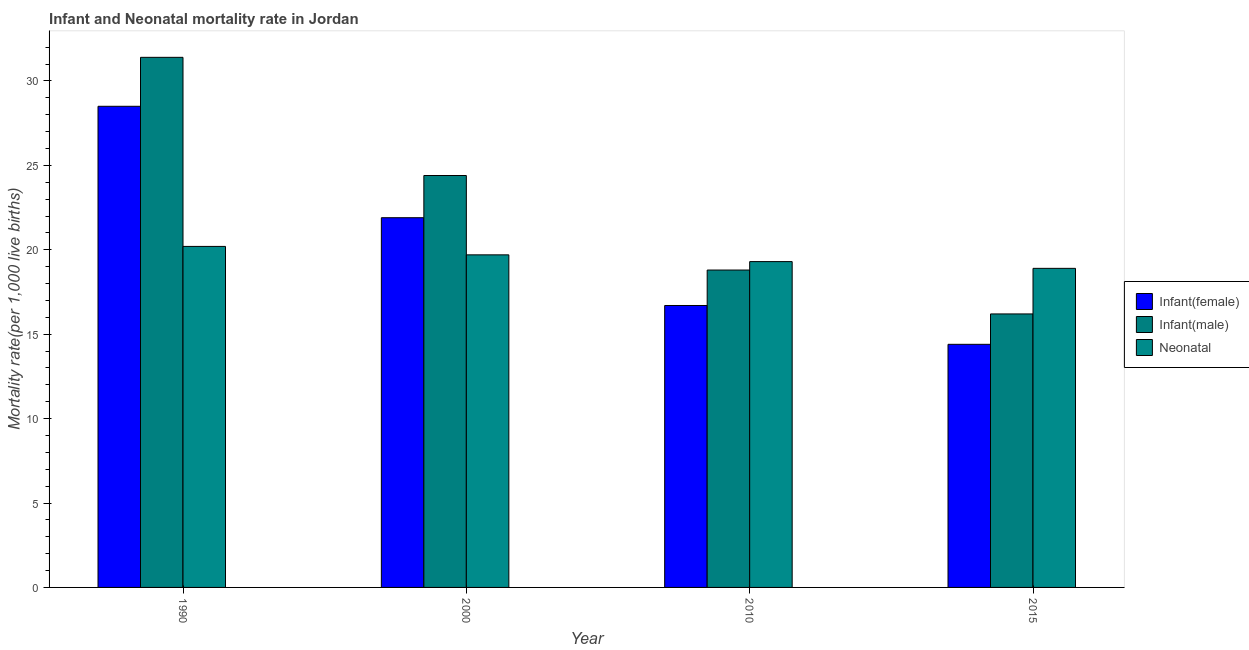How many different coloured bars are there?
Give a very brief answer. 3. Are the number of bars per tick equal to the number of legend labels?
Make the answer very short. Yes. Across all years, what is the maximum neonatal mortality rate?
Provide a succinct answer. 20.2. Across all years, what is the minimum infant mortality rate(female)?
Ensure brevity in your answer.  14.4. In which year was the infant mortality rate(male) minimum?
Keep it short and to the point. 2015. What is the total infant mortality rate(male) in the graph?
Keep it short and to the point. 90.8. What is the difference between the neonatal mortality rate in 2010 and the infant mortality rate(female) in 2015?
Provide a short and direct response. 0.4. What is the average infant mortality rate(female) per year?
Give a very brief answer. 20.38. In the year 1990, what is the difference between the neonatal mortality rate and infant mortality rate(female)?
Your answer should be very brief. 0. In how many years, is the neonatal mortality rate greater than 21?
Offer a terse response. 0. What is the ratio of the neonatal mortality rate in 1990 to that in 2015?
Provide a short and direct response. 1.07. Is the infant mortality rate(male) in 2000 less than that in 2010?
Your answer should be very brief. No. Is the difference between the infant mortality rate(male) in 2000 and 2015 greater than the difference between the neonatal mortality rate in 2000 and 2015?
Make the answer very short. No. What is the difference between the highest and the second highest infant mortality rate(female)?
Offer a terse response. 6.6. What is the difference between the highest and the lowest neonatal mortality rate?
Your answer should be compact. 1.3. What does the 2nd bar from the left in 2015 represents?
Give a very brief answer. Infant(male). What does the 2nd bar from the right in 2000 represents?
Provide a short and direct response. Infant(male). Is it the case that in every year, the sum of the infant mortality rate(female) and infant mortality rate(male) is greater than the neonatal mortality rate?
Your answer should be very brief. Yes. How many years are there in the graph?
Make the answer very short. 4. Does the graph contain any zero values?
Keep it short and to the point. No. How many legend labels are there?
Give a very brief answer. 3. How are the legend labels stacked?
Provide a short and direct response. Vertical. What is the title of the graph?
Offer a terse response. Infant and Neonatal mortality rate in Jordan. What is the label or title of the Y-axis?
Your response must be concise. Mortality rate(per 1,0 live births). What is the Mortality rate(per 1,000 live births) of Infant(female) in 1990?
Keep it short and to the point. 28.5. What is the Mortality rate(per 1,000 live births) of Infant(male) in 1990?
Offer a very short reply. 31.4. What is the Mortality rate(per 1,000 live births) of Neonatal  in 1990?
Give a very brief answer. 20.2. What is the Mortality rate(per 1,000 live births) of Infant(female) in 2000?
Offer a terse response. 21.9. What is the Mortality rate(per 1,000 live births) in Infant(male) in 2000?
Your answer should be compact. 24.4. What is the Mortality rate(per 1,000 live births) of Infant(female) in 2010?
Your answer should be very brief. 16.7. What is the Mortality rate(per 1,000 live births) of Infant(male) in 2010?
Your response must be concise. 18.8. What is the Mortality rate(per 1,000 live births) in Neonatal  in 2010?
Give a very brief answer. 19.3. What is the Mortality rate(per 1,000 live births) in Infant(female) in 2015?
Offer a very short reply. 14.4. What is the Mortality rate(per 1,000 live births) in Infant(male) in 2015?
Offer a very short reply. 16.2. Across all years, what is the maximum Mortality rate(per 1,000 live births) in Infant(male)?
Ensure brevity in your answer.  31.4. Across all years, what is the maximum Mortality rate(per 1,000 live births) of Neonatal ?
Provide a short and direct response. 20.2. Across all years, what is the minimum Mortality rate(per 1,000 live births) in Neonatal ?
Your answer should be very brief. 18.9. What is the total Mortality rate(per 1,000 live births) of Infant(female) in the graph?
Give a very brief answer. 81.5. What is the total Mortality rate(per 1,000 live births) in Infant(male) in the graph?
Offer a terse response. 90.8. What is the total Mortality rate(per 1,000 live births) in Neonatal  in the graph?
Ensure brevity in your answer.  78.1. What is the difference between the Mortality rate(per 1,000 live births) of Infant(female) in 1990 and that in 2010?
Your response must be concise. 11.8. What is the difference between the Mortality rate(per 1,000 live births) in Neonatal  in 1990 and that in 2010?
Keep it short and to the point. 0.9. What is the difference between the Mortality rate(per 1,000 live births) in Infant(male) in 1990 and that in 2015?
Give a very brief answer. 15.2. What is the difference between the Mortality rate(per 1,000 live births) of Infant(female) in 2000 and that in 2010?
Keep it short and to the point. 5.2. What is the difference between the Mortality rate(per 1,000 live births) of Infant(male) in 2000 and that in 2010?
Ensure brevity in your answer.  5.6. What is the difference between the Mortality rate(per 1,000 live births) in Neonatal  in 2000 and that in 2010?
Offer a terse response. 0.4. What is the difference between the Mortality rate(per 1,000 live births) of Infant(female) in 2010 and that in 2015?
Your response must be concise. 2.3. What is the difference between the Mortality rate(per 1,000 live births) of Neonatal  in 2010 and that in 2015?
Your response must be concise. 0.4. What is the difference between the Mortality rate(per 1,000 live births) in Infant(female) in 1990 and the Mortality rate(per 1,000 live births) in Neonatal  in 2000?
Provide a succinct answer. 8.8. What is the difference between the Mortality rate(per 1,000 live births) of Infant(male) in 1990 and the Mortality rate(per 1,000 live births) of Neonatal  in 2000?
Offer a very short reply. 11.7. What is the difference between the Mortality rate(per 1,000 live births) of Infant(female) in 1990 and the Mortality rate(per 1,000 live births) of Infant(male) in 2010?
Ensure brevity in your answer.  9.7. What is the difference between the Mortality rate(per 1,000 live births) of Infant(male) in 1990 and the Mortality rate(per 1,000 live births) of Neonatal  in 2010?
Offer a very short reply. 12.1. What is the difference between the Mortality rate(per 1,000 live births) of Infant(male) in 1990 and the Mortality rate(per 1,000 live births) of Neonatal  in 2015?
Your answer should be very brief. 12.5. What is the difference between the Mortality rate(per 1,000 live births) of Infant(female) in 2000 and the Mortality rate(per 1,000 live births) of Infant(male) in 2010?
Ensure brevity in your answer.  3.1. What is the difference between the Mortality rate(per 1,000 live births) in Infant(female) in 2000 and the Mortality rate(per 1,000 live births) in Neonatal  in 2015?
Ensure brevity in your answer.  3. What is the difference between the Mortality rate(per 1,000 live births) in Infant(male) in 2000 and the Mortality rate(per 1,000 live births) in Neonatal  in 2015?
Keep it short and to the point. 5.5. What is the difference between the Mortality rate(per 1,000 live births) of Infant(female) in 2010 and the Mortality rate(per 1,000 live births) of Neonatal  in 2015?
Your answer should be compact. -2.2. What is the difference between the Mortality rate(per 1,000 live births) in Infant(male) in 2010 and the Mortality rate(per 1,000 live births) in Neonatal  in 2015?
Provide a short and direct response. -0.1. What is the average Mortality rate(per 1,000 live births) in Infant(female) per year?
Your answer should be compact. 20.38. What is the average Mortality rate(per 1,000 live births) in Infant(male) per year?
Your answer should be compact. 22.7. What is the average Mortality rate(per 1,000 live births) in Neonatal  per year?
Make the answer very short. 19.52. In the year 1990, what is the difference between the Mortality rate(per 1,000 live births) of Infant(female) and Mortality rate(per 1,000 live births) of Infant(male)?
Your answer should be very brief. -2.9. In the year 1990, what is the difference between the Mortality rate(per 1,000 live births) of Infant(female) and Mortality rate(per 1,000 live births) of Neonatal ?
Provide a short and direct response. 8.3. In the year 2000, what is the difference between the Mortality rate(per 1,000 live births) in Infant(female) and Mortality rate(per 1,000 live births) in Neonatal ?
Offer a terse response. 2.2. In the year 2000, what is the difference between the Mortality rate(per 1,000 live births) in Infant(male) and Mortality rate(per 1,000 live births) in Neonatal ?
Provide a short and direct response. 4.7. In the year 2010, what is the difference between the Mortality rate(per 1,000 live births) of Infant(female) and Mortality rate(per 1,000 live births) of Infant(male)?
Your answer should be compact. -2.1. In the year 2015, what is the difference between the Mortality rate(per 1,000 live births) in Infant(female) and Mortality rate(per 1,000 live births) in Infant(male)?
Keep it short and to the point. -1.8. In the year 2015, what is the difference between the Mortality rate(per 1,000 live births) of Infant(female) and Mortality rate(per 1,000 live births) of Neonatal ?
Your answer should be very brief. -4.5. What is the ratio of the Mortality rate(per 1,000 live births) of Infant(female) in 1990 to that in 2000?
Your answer should be very brief. 1.3. What is the ratio of the Mortality rate(per 1,000 live births) in Infant(male) in 1990 to that in 2000?
Give a very brief answer. 1.29. What is the ratio of the Mortality rate(per 1,000 live births) in Neonatal  in 1990 to that in 2000?
Keep it short and to the point. 1.03. What is the ratio of the Mortality rate(per 1,000 live births) in Infant(female) in 1990 to that in 2010?
Offer a very short reply. 1.71. What is the ratio of the Mortality rate(per 1,000 live births) of Infant(male) in 1990 to that in 2010?
Offer a terse response. 1.67. What is the ratio of the Mortality rate(per 1,000 live births) of Neonatal  in 1990 to that in 2010?
Offer a very short reply. 1.05. What is the ratio of the Mortality rate(per 1,000 live births) in Infant(female) in 1990 to that in 2015?
Your answer should be very brief. 1.98. What is the ratio of the Mortality rate(per 1,000 live births) in Infant(male) in 1990 to that in 2015?
Make the answer very short. 1.94. What is the ratio of the Mortality rate(per 1,000 live births) in Neonatal  in 1990 to that in 2015?
Offer a terse response. 1.07. What is the ratio of the Mortality rate(per 1,000 live births) in Infant(female) in 2000 to that in 2010?
Make the answer very short. 1.31. What is the ratio of the Mortality rate(per 1,000 live births) of Infant(male) in 2000 to that in 2010?
Offer a very short reply. 1.3. What is the ratio of the Mortality rate(per 1,000 live births) in Neonatal  in 2000 to that in 2010?
Provide a short and direct response. 1.02. What is the ratio of the Mortality rate(per 1,000 live births) of Infant(female) in 2000 to that in 2015?
Provide a succinct answer. 1.52. What is the ratio of the Mortality rate(per 1,000 live births) of Infant(male) in 2000 to that in 2015?
Provide a succinct answer. 1.51. What is the ratio of the Mortality rate(per 1,000 live births) of Neonatal  in 2000 to that in 2015?
Provide a short and direct response. 1.04. What is the ratio of the Mortality rate(per 1,000 live births) in Infant(female) in 2010 to that in 2015?
Provide a short and direct response. 1.16. What is the ratio of the Mortality rate(per 1,000 live births) of Infant(male) in 2010 to that in 2015?
Offer a terse response. 1.16. What is the ratio of the Mortality rate(per 1,000 live births) of Neonatal  in 2010 to that in 2015?
Provide a succinct answer. 1.02. What is the difference between the highest and the second highest Mortality rate(per 1,000 live births) of Infant(male)?
Your answer should be very brief. 7. What is the difference between the highest and the lowest Mortality rate(per 1,000 live births) of Infant(male)?
Offer a very short reply. 15.2. 